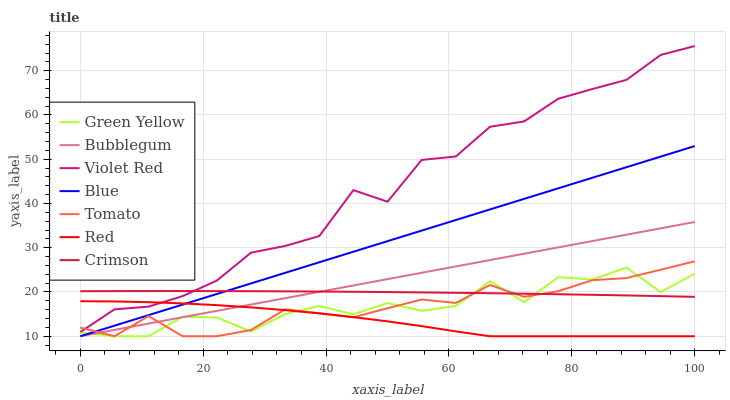Does Red have the minimum area under the curve?
Answer yes or no. Yes. Does Violet Red have the maximum area under the curve?
Answer yes or no. Yes. Does Tomato have the minimum area under the curve?
Answer yes or no. No. Does Tomato have the maximum area under the curve?
Answer yes or no. No. Is Blue the smoothest?
Answer yes or no. Yes. Is Green Yellow the roughest?
Answer yes or no. Yes. Is Tomato the smoothest?
Answer yes or no. No. Is Tomato the roughest?
Answer yes or no. No. Does Blue have the lowest value?
Answer yes or no. Yes. Does Violet Red have the lowest value?
Answer yes or no. No. Does Violet Red have the highest value?
Answer yes or no. Yes. Does Tomato have the highest value?
Answer yes or no. No. Is Blue less than Violet Red?
Answer yes or no. Yes. Is Crimson greater than Red?
Answer yes or no. Yes. Does Bubblegum intersect Green Yellow?
Answer yes or no. Yes. Is Bubblegum less than Green Yellow?
Answer yes or no. No. Is Bubblegum greater than Green Yellow?
Answer yes or no. No. Does Blue intersect Violet Red?
Answer yes or no. No. 